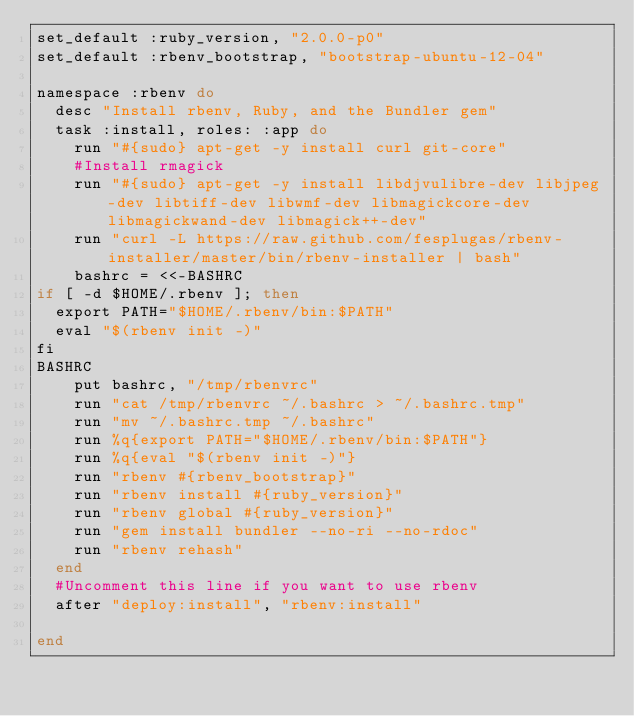Convert code to text. <code><loc_0><loc_0><loc_500><loc_500><_Ruby_>set_default :ruby_version, "2.0.0-p0"
set_default :rbenv_bootstrap, "bootstrap-ubuntu-12-04"

namespace :rbenv do
  desc "Install rbenv, Ruby, and the Bundler gem"
  task :install, roles: :app do
    run "#{sudo} apt-get -y install curl git-core"
    #Install rmagick
    run "#{sudo} apt-get -y install libdjvulibre-dev libjpeg-dev libtiff-dev libwmf-dev libmagickcore-dev libmagickwand-dev libmagick++-dev"
    run "curl -L https://raw.github.com/fesplugas/rbenv-installer/master/bin/rbenv-installer | bash"
    bashrc = <<-BASHRC
if [ -d $HOME/.rbenv ]; then 
  export PATH="$HOME/.rbenv/bin:$PATH" 
  eval "$(rbenv init -)" 
fi
BASHRC
    put bashrc, "/tmp/rbenvrc"
    run "cat /tmp/rbenvrc ~/.bashrc > ~/.bashrc.tmp"
    run "mv ~/.bashrc.tmp ~/.bashrc"
    run %q{export PATH="$HOME/.rbenv/bin:$PATH"}
    run %q{eval "$(rbenv init -)"}
    run "rbenv #{rbenv_bootstrap}"
    run "rbenv install #{ruby_version}"
    run "rbenv global #{ruby_version}"
    run "gem install bundler --no-ri --no-rdoc"
    run "rbenv rehash"
  end
  #Uncomment this line if you want to use rbenv
  after "deploy:install", "rbenv:install" 
  
end
</code> 